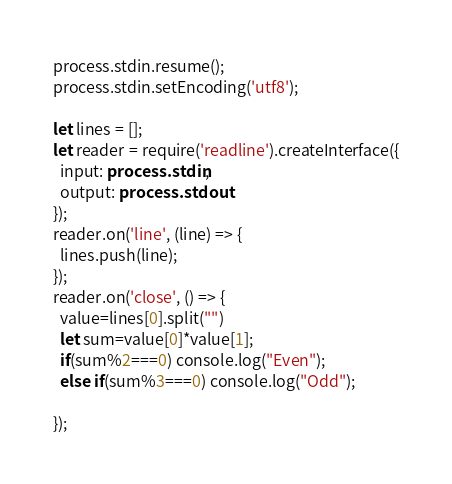<code> <loc_0><loc_0><loc_500><loc_500><_TypeScript_>process.stdin.resume();
process.stdin.setEncoding('utf8');

let lines = [];
let reader = require('readline').createInterface({
  input: process.stdin,
  output: process.stdout
});
reader.on('line', (line) => {
  lines.push(line);
});
reader.on('close', () => {
  value=lines[0].split("")
  let sum=value[0]*value[1];
  if(sum%2===0) console.log("Even");
  else if(sum%3===0) console.log("Odd");
  
});</code> 